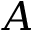<formula> <loc_0><loc_0><loc_500><loc_500>A</formula> 